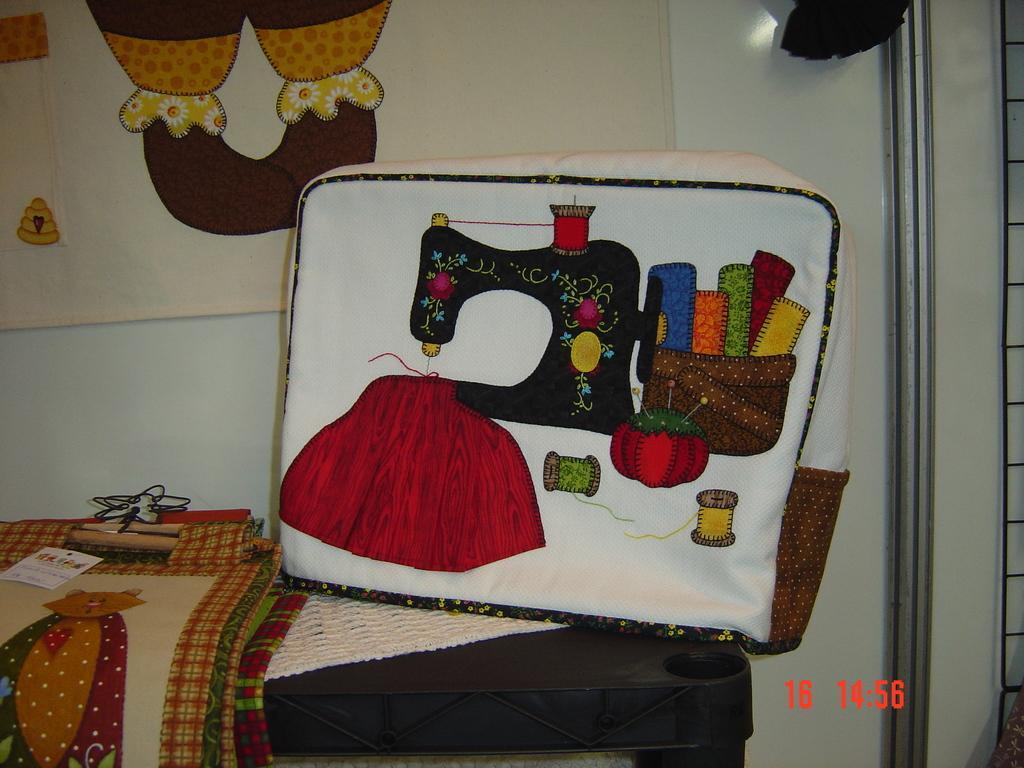Describe this image in one or two sentences. In this image, we can see a table in front of the wall contains some bags. There is a designed cloth at the top of the image. 